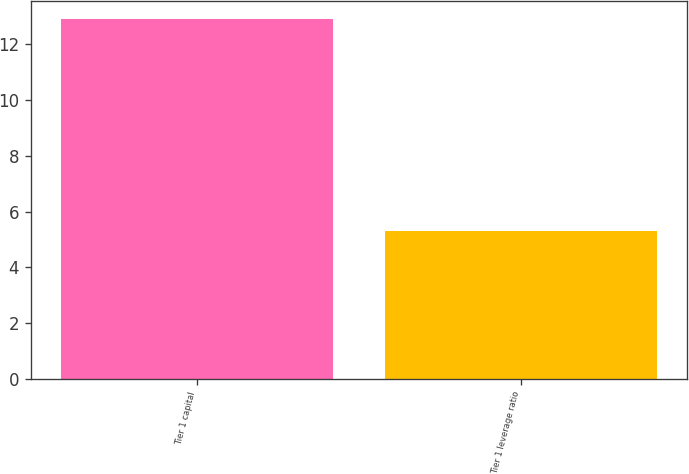<chart> <loc_0><loc_0><loc_500><loc_500><bar_chart><fcel>Tier 1 capital<fcel>Tier 1 leverage ratio<nl><fcel>12.9<fcel>5.3<nl></chart> 